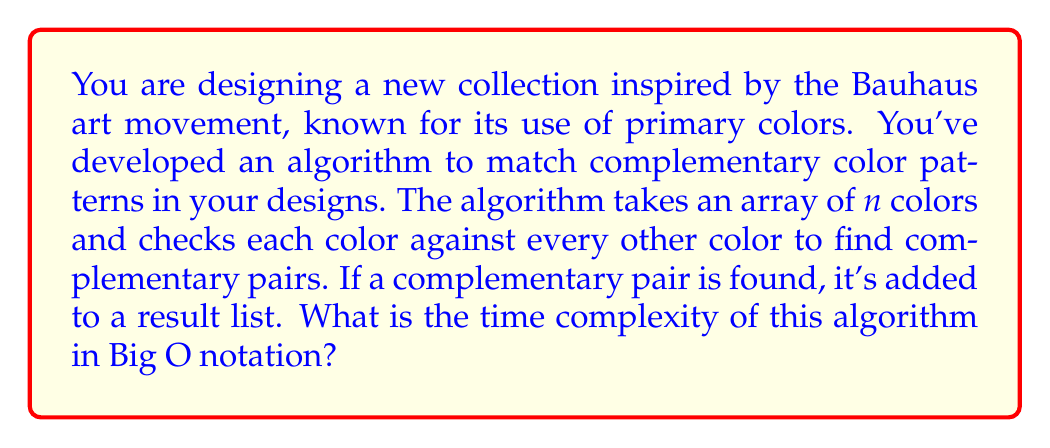Could you help me with this problem? Let's analyze the algorithm step by step:

1) The algorithm takes an array of $n$ colors as input.

2) For each color in the array, it needs to check against every other color:
   - The outer loop runs $n$ times (once for each color)
   - For each iteration of the outer loop, the inner loop runs $(n-1)$ times (checking against all other colors except itself)

3) This creates a nested loop structure that looks like:

   ```
   for i = 1 to n:
       for j = 1 to n:
           if i != j and are_complementary(color[i], color[j]):
               add_to_result_list(color[i], color[j])
   ```

4) The total number of comparisons made is:

   $$(n-1) + (n-1) + ... + (n-1) = n(n-1)$$

   This is because we have $n$ iterations of the outer loop, each doing $(n-1)$ comparisons.

5) Expanding this:

   $$n(n-1) = n^2 - n$$

6) In Big O notation, we're concerned with the dominant term as $n$ grows large. Here, the $n^2$ term dominates, and we can drop the lower-order terms and constants.

Therefore, the time complexity of this algorithm is $O(n^2)$.

This quadratic time complexity means that as the number of colors in your palette increases, the time taken by the algorithm increases quadratically, which could become inefficient for very large color sets.
Answer: $O(n^2)$ 